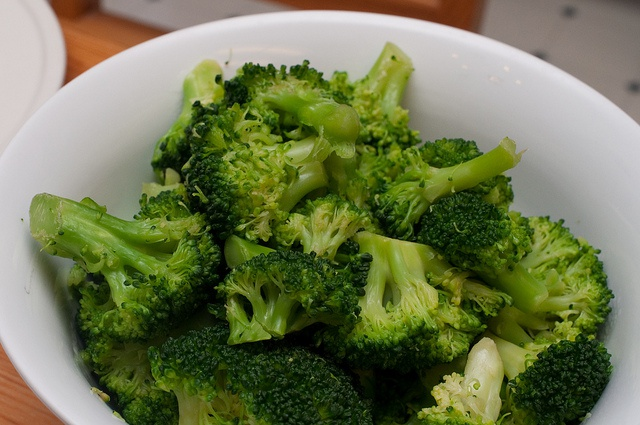Describe the objects in this image and their specific colors. I can see dining table in black, lightgray, darkgray, and darkgreen tones, bowl in black, lightgray, darkgreen, and darkgray tones, broccoli in lightgray, black, darkgreen, and olive tones, broccoli in lightgray, black, and darkgreen tones, and broccoli in lightgray, black, darkgreen, and olive tones in this image. 